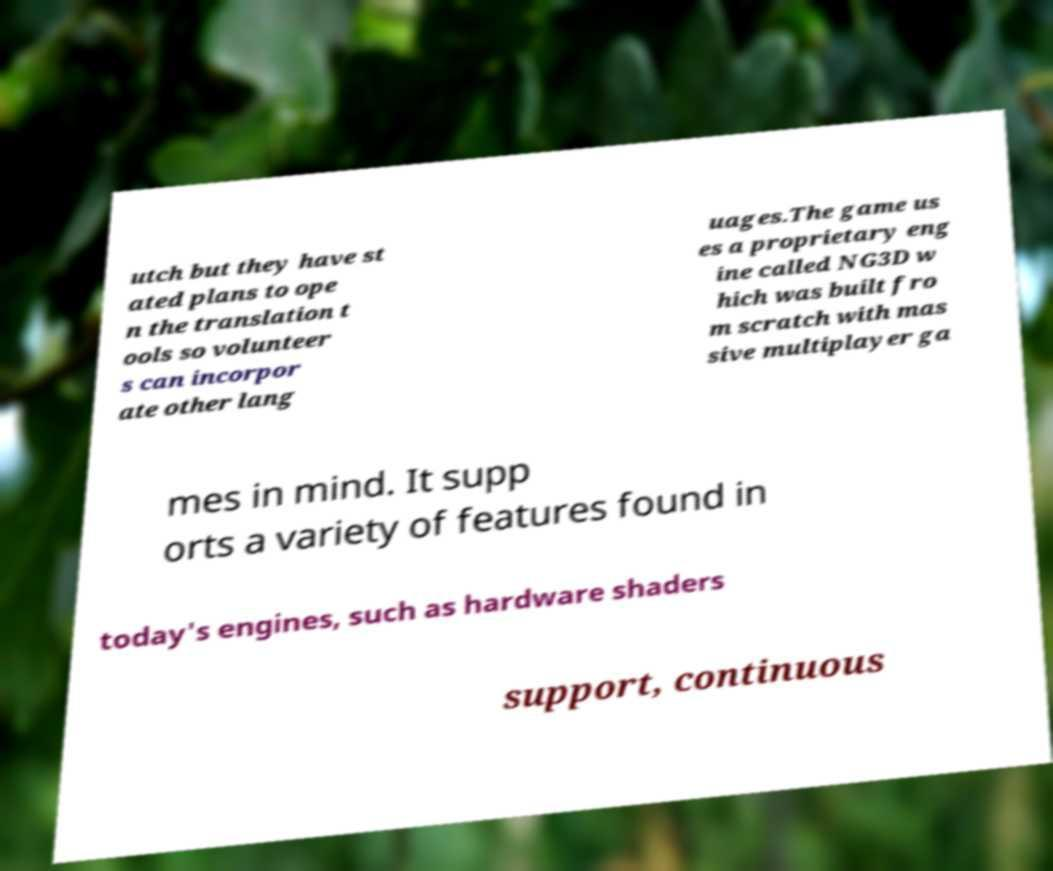For documentation purposes, I need the text within this image transcribed. Could you provide that? utch but they have st ated plans to ope n the translation t ools so volunteer s can incorpor ate other lang uages.The game us es a proprietary eng ine called NG3D w hich was built fro m scratch with mas sive multiplayer ga mes in mind. It supp orts a variety of features found in today's engines, such as hardware shaders support, continuous 